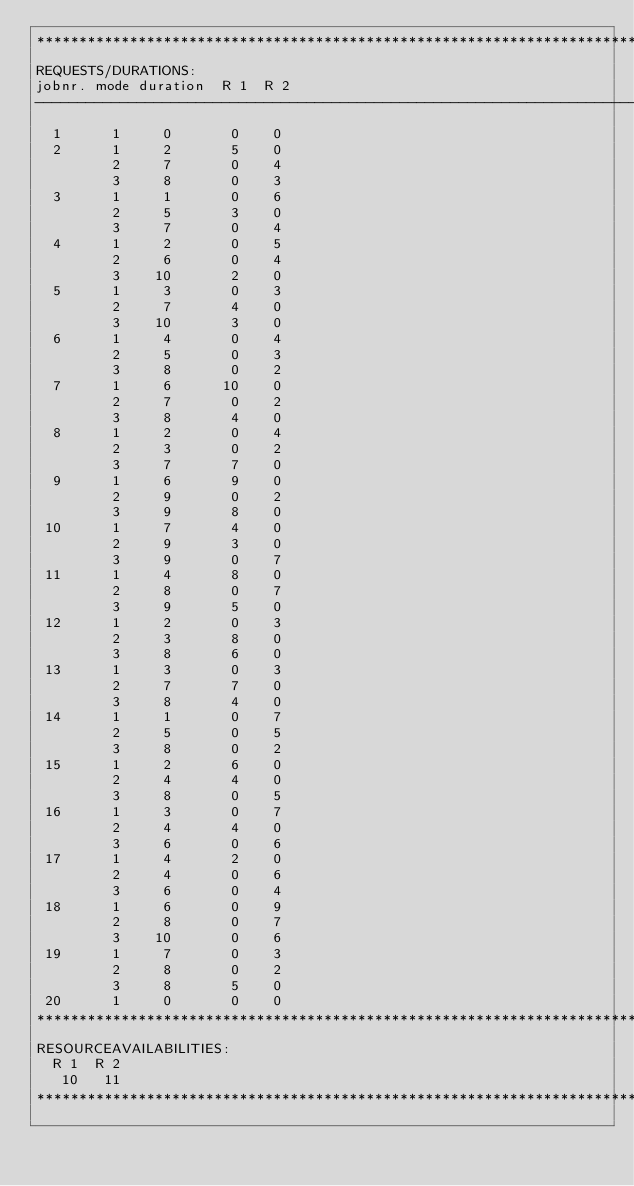Convert code to text. <code><loc_0><loc_0><loc_500><loc_500><_ObjectiveC_>************************************************************************
REQUESTS/DURATIONS:
jobnr. mode duration  R 1  R 2
------------------------------------------------------------------------
  1      1     0       0    0
  2      1     2       5    0
         2     7       0    4
         3     8       0    3
  3      1     1       0    6
         2     5       3    0
         3     7       0    4
  4      1     2       0    5
         2     6       0    4
         3    10       2    0
  5      1     3       0    3
         2     7       4    0
         3    10       3    0
  6      1     4       0    4
         2     5       0    3
         3     8       0    2
  7      1     6      10    0
         2     7       0    2
         3     8       4    0
  8      1     2       0    4
         2     3       0    2
         3     7       7    0
  9      1     6       9    0
         2     9       0    2
         3     9       8    0
 10      1     7       4    0
         2     9       3    0
         3     9       0    7
 11      1     4       8    0
         2     8       0    7
         3     9       5    0
 12      1     2       0    3
         2     3       8    0
         3     8       6    0
 13      1     3       0    3
         2     7       7    0
         3     8       4    0
 14      1     1       0    7
         2     5       0    5
         3     8       0    2
 15      1     2       6    0
         2     4       4    0
         3     8       0    5
 16      1     3       0    7
         2     4       4    0
         3     6       0    6
 17      1     4       2    0
         2     4       0    6
         3     6       0    4
 18      1     6       0    9
         2     8       0    7
         3    10       0    6
 19      1     7       0    3
         2     8       0    2
         3     8       5    0
 20      1     0       0    0
************************************************************************
RESOURCEAVAILABILITIES:
  R 1  R 2
   10   11
************************************************************************
</code> 